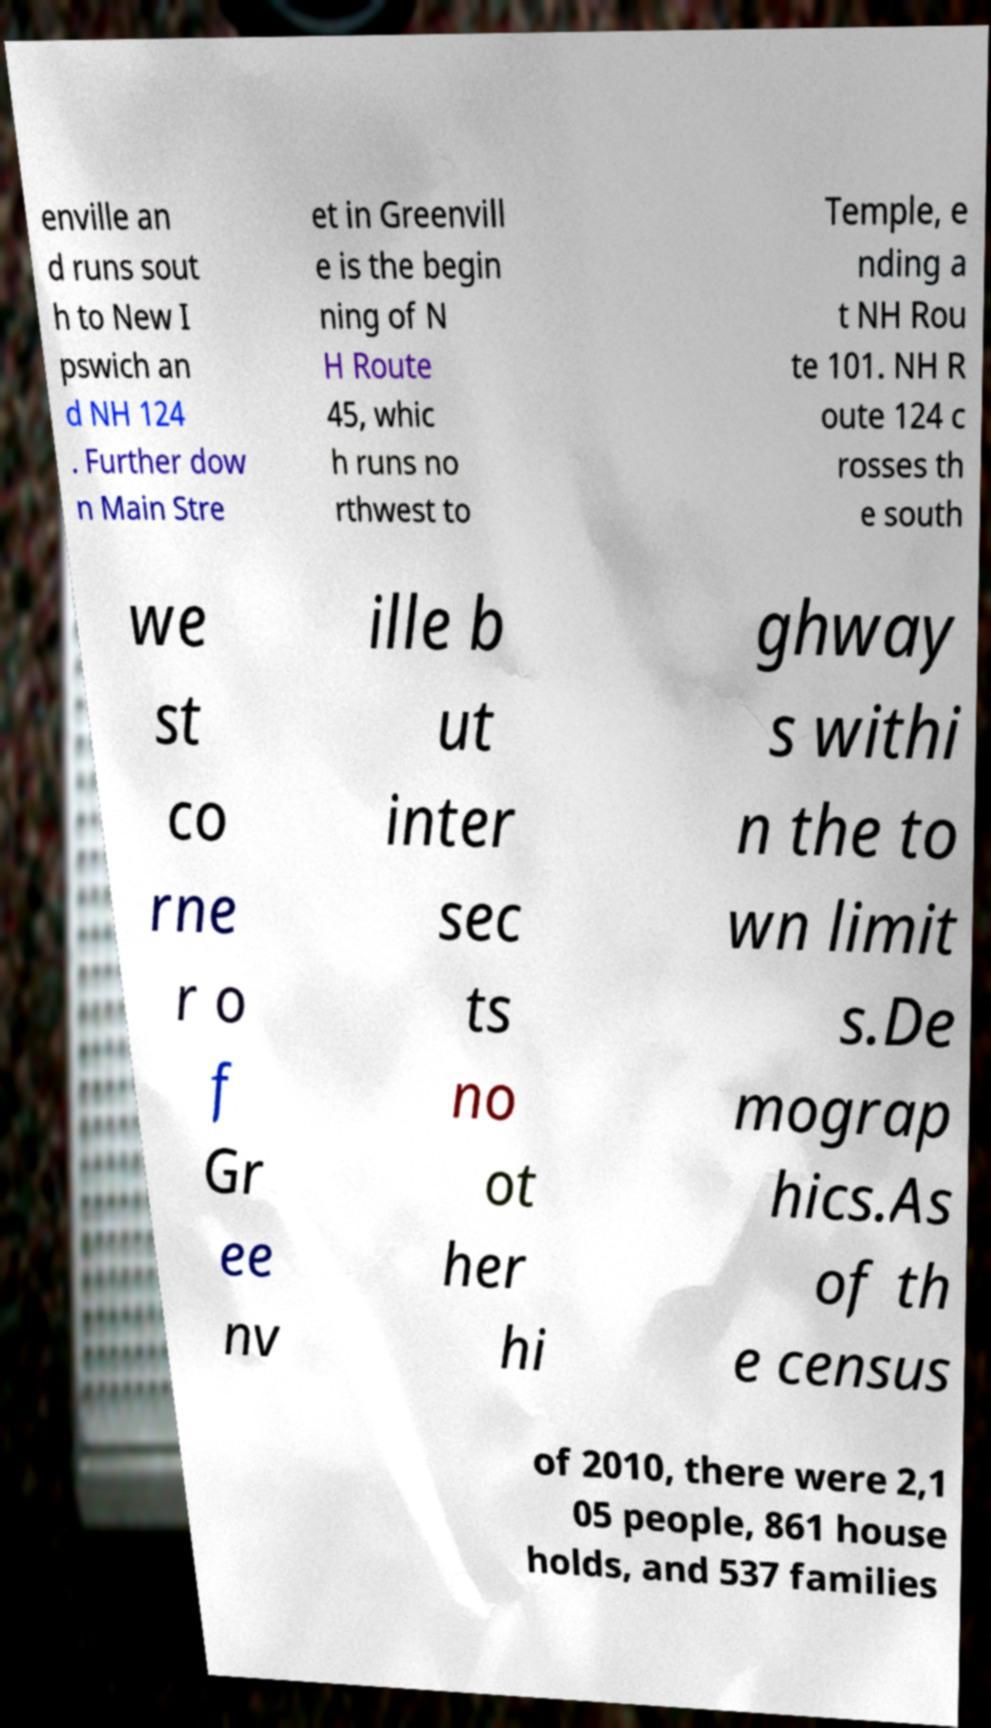I need the written content from this picture converted into text. Can you do that? enville an d runs sout h to New I pswich an d NH 124 . Further dow n Main Stre et in Greenvill e is the begin ning of N H Route 45, whic h runs no rthwest to Temple, e nding a t NH Rou te 101. NH R oute 124 c rosses th e south we st co rne r o f Gr ee nv ille b ut inter sec ts no ot her hi ghway s withi n the to wn limit s.De mograp hics.As of th e census of 2010, there were 2,1 05 people, 861 house holds, and 537 families 